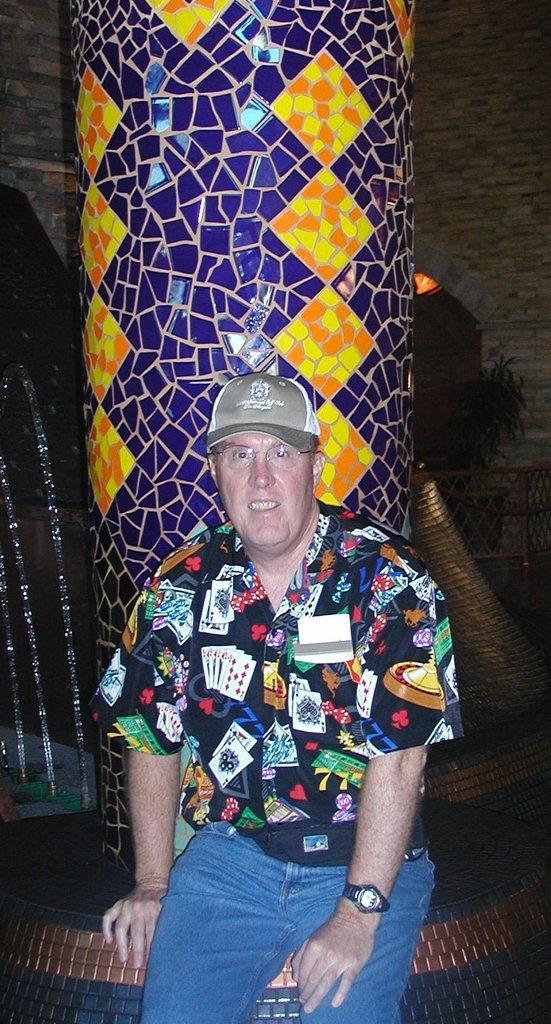Who is the main subject in the picture? There is an old man in the picture. What is the old man wearing? The old man is wearing a colorful shirt and blue jeans. What is the old man doing in the picture? The old man is sitting and posing for the camera. What can be seen in the background of the image? There is a blue and yellow color pillar in the background of the image. How many sticks are the old man holding in the image? There are no sticks present in the image. What number is written on the old man's shirt? There is no number written on the old man's shirt; it is a colorful shirt without any visible numbers. 